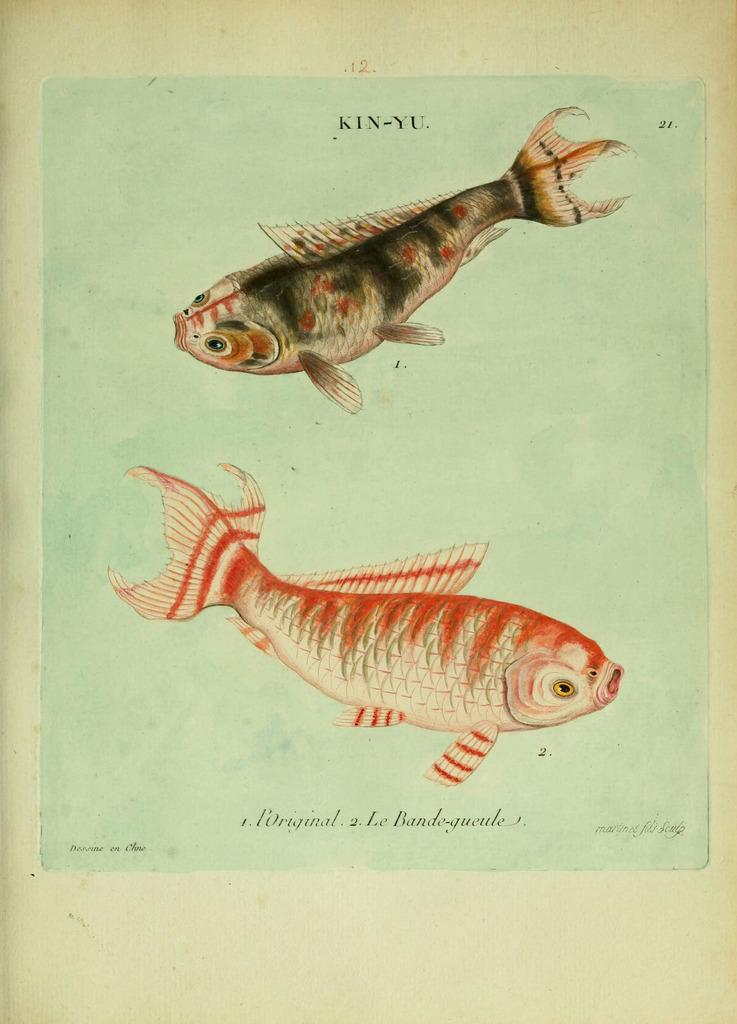What type of artwork is depicted in the image? The image is a painting. What is the main subject of the painting? There are fishes in the painting. Are there any words or letters in the painting? Yes, there is some text in the painting. What type of loaf is being prepared by the judge in the painting? There is no loaf or judge present in the painting; it features fishes and text. Can you tell me how many cannons are visible in the painting? There are no cannons present in the painting; it features fishes and text. 